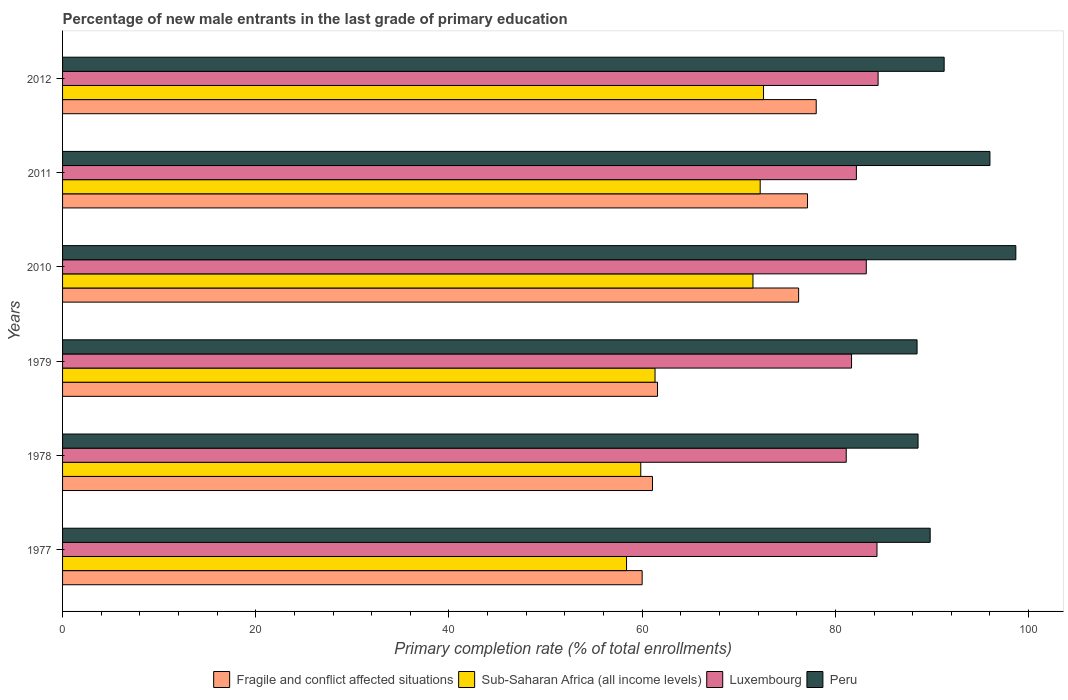Are the number of bars per tick equal to the number of legend labels?
Provide a succinct answer. Yes. Are the number of bars on each tick of the Y-axis equal?
Offer a very short reply. Yes. How many bars are there on the 3rd tick from the top?
Your answer should be compact. 4. How many bars are there on the 1st tick from the bottom?
Ensure brevity in your answer.  4. What is the label of the 5th group of bars from the top?
Your answer should be very brief. 1978. In how many cases, is the number of bars for a given year not equal to the number of legend labels?
Provide a short and direct response. 0. What is the percentage of new male entrants in Luxembourg in 1977?
Your response must be concise. 84.31. Across all years, what is the maximum percentage of new male entrants in Sub-Saharan Africa (all income levels)?
Offer a very short reply. 72.56. Across all years, what is the minimum percentage of new male entrants in Fragile and conflict affected situations?
Ensure brevity in your answer.  60. In which year was the percentage of new male entrants in Sub-Saharan Africa (all income levels) minimum?
Keep it short and to the point. 1977. What is the total percentage of new male entrants in Sub-Saharan Africa (all income levels) in the graph?
Your response must be concise. 395.82. What is the difference between the percentage of new male entrants in Peru in 1978 and that in 2011?
Offer a very short reply. -7.44. What is the difference between the percentage of new male entrants in Luxembourg in 1979 and the percentage of new male entrants in Peru in 2012?
Make the answer very short. -9.59. What is the average percentage of new male entrants in Peru per year?
Make the answer very short. 92.13. In the year 1977, what is the difference between the percentage of new male entrants in Peru and percentage of new male entrants in Luxembourg?
Your answer should be very brief. 5.51. What is the ratio of the percentage of new male entrants in Sub-Saharan Africa (all income levels) in 1977 to that in 2011?
Your response must be concise. 0.81. Is the difference between the percentage of new male entrants in Peru in 1979 and 2011 greater than the difference between the percentage of new male entrants in Luxembourg in 1979 and 2011?
Ensure brevity in your answer.  No. What is the difference between the highest and the second highest percentage of new male entrants in Luxembourg?
Ensure brevity in your answer.  0.12. What is the difference between the highest and the lowest percentage of new male entrants in Luxembourg?
Provide a succinct answer. 3.3. In how many years, is the percentage of new male entrants in Fragile and conflict affected situations greater than the average percentage of new male entrants in Fragile and conflict affected situations taken over all years?
Offer a very short reply. 3. Is the sum of the percentage of new male entrants in Luxembourg in 2010 and 2012 greater than the maximum percentage of new male entrants in Peru across all years?
Ensure brevity in your answer.  Yes. Is it the case that in every year, the sum of the percentage of new male entrants in Sub-Saharan Africa (all income levels) and percentage of new male entrants in Luxembourg is greater than the sum of percentage of new male entrants in Peru and percentage of new male entrants in Fragile and conflict affected situations?
Your response must be concise. No. What does the 4th bar from the top in 2011 represents?
Ensure brevity in your answer.  Fragile and conflict affected situations. What does the 3rd bar from the bottom in 2011 represents?
Provide a short and direct response. Luxembourg. Is it the case that in every year, the sum of the percentage of new male entrants in Luxembourg and percentage of new male entrants in Fragile and conflict affected situations is greater than the percentage of new male entrants in Peru?
Your answer should be compact. Yes. Does the graph contain any zero values?
Offer a very short reply. No. Does the graph contain grids?
Make the answer very short. No. Where does the legend appear in the graph?
Give a very brief answer. Bottom center. How many legend labels are there?
Your answer should be very brief. 4. What is the title of the graph?
Provide a short and direct response. Percentage of new male entrants in the last grade of primary education. What is the label or title of the X-axis?
Keep it short and to the point. Primary completion rate (% of total enrollments). What is the Primary completion rate (% of total enrollments) of Fragile and conflict affected situations in 1977?
Give a very brief answer. 60. What is the Primary completion rate (% of total enrollments) in Sub-Saharan Africa (all income levels) in 1977?
Provide a succinct answer. 58.38. What is the Primary completion rate (% of total enrollments) in Luxembourg in 1977?
Your answer should be compact. 84.31. What is the Primary completion rate (% of total enrollments) of Peru in 1977?
Your answer should be compact. 89.82. What is the Primary completion rate (% of total enrollments) of Fragile and conflict affected situations in 1978?
Offer a terse response. 61.07. What is the Primary completion rate (% of total enrollments) in Sub-Saharan Africa (all income levels) in 1978?
Provide a succinct answer. 59.85. What is the Primary completion rate (% of total enrollments) in Luxembourg in 1978?
Your answer should be very brief. 81.13. What is the Primary completion rate (% of total enrollments) of Peru in 1978?
Provide a short and direct response. 88.56. What is the Primary completion rate (% of total enrollments) of Fragile and conflict affected situations in 1979?
Give a very brief answer. 61.59. What is the Primary completion rate (% of total enrollments) of Sub-Saharan Africa (all income levels) in 1979?
Keep it short and to the point. 61.33. What is the Primary completion rate (% of total enrollments) of Luxembourg in 1979?
Provide a short and direct response. 81.68. What is the Primary completion rate (% of total enrollments) in Peru in 1979?
Your answer should be compact. 88.46. What is the Primary completion rate (% of total enrollments) of Fragile and conflict affected situations in 2010?
Ensure brevity in your answer.  76.2. What is the Primary completion rate (% of total enrollments) in Sub-Saharan Africa (all income levels) in 2010?
Provide a short and direct response. 71.47. What is the Primary completion rate (% of total enrollments) of Luxembourg in 2010?
Offer a very short reply. 83.2. What is the Primary completion rate (% of total enrollments) in Peru in 2010?
Ensure brevity in your answer.  98.68. What is the Primary completion rate (% of total enrollments) of Fragile and conflict affected situations in 2011?
Offer a terse response. 77.12. What is the Primary completion rate (% of total enrollments) in Sub-Saharan Africa (all income levels) in 2011?
Offer a very short reply. 72.22. What is the Primary completion rate (% of total enrollments) in Luxembourg in 2011?
Offer a very short reply. 82.18. What is the Primary completion rate (% of total enrollments) in Peru in 2011?
Your answer should be very brief. 96. What is the Primary completion rate (% of total enrollments) of Fragile and conflict affected situations in 2012?
Offer a terse response. 78.02. What is the Primary completion rate (% of total enrollments) of Sub-Saharan Africa (all income levels) in 2012?
Make the answer very short. 72.56. What is the Primary completion rate (% of total enrollments) of Luxembourg in 2012?
Offer a very short reply. 84.42. What is the Primary completion rate (% of total enrollments) in Peru in 2012?
Keep it short and to the point. 91.26. Across all years, what is the maximum Primary completion rate (% of total enrollments) of Fragile and conflict affected situations?
Your answer should be compact. 78.02. Across all years, what is the maximum Primary completion rate (% of total enrollments) of Sub-Saharan Africa (all income levels)?
Ensure brevity in your answer.  72.56. Across all years, what is the maximum Primary completion rate (% of total enrollments) in Luxembourg?
Offer a very short reply. 84.42. Across all years, what is the maximum Primary completion rate (% of total enrollments) in Peru?
Offer a very short reply. 98.68. Across all years, what is the minimum Primary completion rate (% of total enrollments) of Fragile and conflict affected situations?
Offer a terse response. 60. Across all years, what is the minimum Primary completion rate (% of total enrollments) in Sub-Saharan Africa (all income levels)?
Offer a very short reply. 58.38. Across all years, what is the minimum Primary completion rate (% of total enrollments) of Luxembourg?
Provide a succinct answer. 81.13. Across all years, what is the minimum Primary completion rate (% of total enrollments) of Peru?
Your response must be concise. 88.46. What is the total Primary completion rate (% of total enrollments) of Fragile and conflict affected situations in the graph?
Provide a succinct answer. 413.99. What is the total Primary completion rate (% of total enrollments) in Sub-Saharan Africa (all income levels) in the graph?
Your response must be concise. 395.82. What is the total Primary completion rate (% of total enrollments) of Luxembourg in the graph?
Keep it short and to the point. 496.91. What is the total Primary completion rate (% of total enrollments) in Peru in the graph?
Your answer should be very brief. 552.78. What is the difference between the Primary completion rate (% of total enrollments) in Fragile and conflict affected situations in 1977 and that in 1978?
Your answer should be very brief. -1.07. What is the difference between the Primary completion rate (% of total enrollments) in Sub-Saharan Africa (all income levels) in 1977 and that in 1978?
Your answer should be very brief. -1.47. What is the difference between the Primary completion rate (% of total enrollments) in Luxembourg in 1977 and that in 1978?
Your answer should be compact. 3.18. What is the difference between the Primary completion rate (% of total enrollments) in Peru in 1977 and that in 1978?
Your answer should be compact. 1.25. What is the difference between the Primary completion rate (% of total enrollments) of Fragile and conflict affected situations in 1977 and that in 1979?
Keep it short and to the point. -1.59. What is the difference between the Primary completion rate (% of total enrollments) of Sub-Saharan Africa (all income levels) in 1977 and that in 1979?
Offer a terse response. -2.95. What is the difference between the Primary completion rate (% of total enrollments) in Luxembourg in 1977 and that in 1979?
Give a very brief answer. 2.63. What is the difference between the Primary completion rate (% of total enrollments) in Peru in 1977 and that in 1979?
Ensure brevity in your answer.  1.36. What is the difference between the Primary completion rate (% of total enrollments) of Fragile and conflict affected situations in 1977 and that in 2010?
Give a very brief answer. -16.2. What is the difference between the Primary completion rate (% of total enrollments) of Sub-Saharan Africa (all income levels) in 1977 and that in 2010?
Provide a succinct answer. -13.09. What is the difference between the Primary completion rate (% of total enrollments) in Luxembourg in 1977 and that in 2010?
Your answer should be compact. 1.11. What is the difference between the Primary completion rate (% of total enrollments) of Peru in 1977 and that in 2010?
Keep it short and to the point. -8.87. What is the difference between the Primary completion rate (% of total enrollments) of Fragile and conflict affected situations in 1977 and that in 2011?
Your answer should be very brief. -17.12. What is the difference between the Primary completion rate (% of total enrollments) in Sub-Saharan Africa (all income levels) in 1977 and that in 2011?
Offer a very short reply. -13.83. What is the difference between the Primary completion rate (% of total enrollments) of Luxembourg in 1977 and that in 2011?
Your answer should be compact. 2.13. What is the difference between the Primary completion rate (% of total enrollments) of Peru in 1977 and that in 2011?
Ensure brevity in your answer.  -6.19. What is the difference between the Primary completion rate (% of total enrollments) in Fragile and conflict affected situations in 1977 and that in 2012?
Provide a succinct answer. -18.02. What is the difference between the Primary completion rate (% of total enrollments) in Sub-Saharan Africa (all income levels) in 1977 and that in 2012?
Your response must be concise. -14.18. What is the difference between the Primary completion rate (% of total enrollments) in Luxembourg in 1977 and that in 2012?
Your response must be concise. -0.12. What is the difference between the Primary completion rate (% of total enrollments) in Peru in 1977 and that in 2012?
Make the answer very short. -1.45. What is the difference between the Primary completion rate (% of total enrollments) in Fragile and conflict affected situations in 1978 and that in 1979?
Keep it short and to the point. -0.52. What is the difference between the Primary completion rate (% of total enrollments) in Sub-Saharan Africa (all income levels) in 1978 and that in 1979?
Make the answer very short. -1.48. What is the difference between the Primary completion rate (% of total enrollments) in Luxembourg in 1978 and that in 1979?
Offer a terse response. -0.55. What is the difference between the Primary completion rate (% of total enrollments) of Peru in 1978 and that in 1979?
Ensure brevity in your answer.  0.1. What is the difference between the Primary completion rate (% of total enrollments) in Fragile and conflict affected situations in 1978 and that in 2010?
Offer a very short reply. -15.13. What is the difference between the Primary completion rate (% of total enrollments) of Sub-Saharan Africa (all income levels) in 1978 and that in 2010?
Ensure brevity in your answer.  -11.62. What is the difference between the Primary completion rate (% of total enrollments) of Luxembourg in 1978 and that in 2010?
Your response must be concise. -2.08. What is the difference between the Primary completion rate (% of total enrollments) of Peru in 1978 and that in 2010?
Offer a very short reply. -10.12. What is the difference between the Primary completion rate (% of total enrollments) of Fragile and conflict affected situations in 1978 and that in 2011?
Keep it short and to the point. -16.05. What is the difference between the Primary completion rate (% of total enrollments) in Sub-Saharan Africa (all income levels) in 1978 and that in 2011?
Give a very brief answer. -12.36. What is the difference between the Primary completion rate (% of total enrollments) of Luxembourg in 1978 and that in 2011?
Provide a short and direct response. -1.05. What is the difference between the Primary completion rate (% of total enrollments) of Peru in 1978 and that in 2011?
Your answer should be compact. -7.44. What is the difference between the Primary completion rate (% of total enrollments) in Fragile and conflict affected situations in 1978 and that in 2012?
Provide a short and direct response. -16.95. What is the difference between the Primary completion rate (% of total enrollments) in Sub-Saharan Africa (all income levels) in 1978 and that in 2012?
Keep it short and to the point. -12.71. What is the difference between the Primary completion rate (% of total enrollments) in Luxembourg in 1978 and that in 2012?
Offer a terse response. -3.3. What is the difference between the Primary completion rate (% of total enrollments) of Peru in 1978 and that in 2012?
Give a very brief answer. -2.7. What is the difference between the Primary completion rate (% of total enrollments) in Fragile and conflict affected situations in 1979 and that in 2010?
Your answer should be compact. -14.61. What is the difference between the Primary completion rate (% of total enrollments) of Sub-Saharan Africa (all income levels) in 1979 and that in 2010?
Your answer should be very brief. -10.14. What is the difference between the Primary completion rate (% of total enrollments) of Luxembourg in 1979 and that in 2010?
Offer a very short reply. -1.52. What is the difference between the Primary completion rate (% of total enrollments) of Peru in 1979 and that in 2010?
Make the answer very short. -10.22. What is the difference between the Primary completion rate (% of total enrollments) in Fragile and conflict affected situations in 1979 and that in 2011?
Ensure brevity in your answer.  -15.53. What is the difference between the Primary completion rate (% of total enrollments) of Sub-Saharan Africa (all income levels) in 1979 and that in 2011?
Provide a short and direct response. -10.88. What is the difference between the Primary completion rate (% of total enrollments) of Luxembourg in 1979 and that in 2011?
Keep it short and to the point. -0.5. What is the difference between the Primary completion rate (% of total enrollments) in Peru in 1979 and that in 2011?
Provide a short and direct response. -7.54. What is the difference between the Primary completion rate (% of total enrollments) of Fragile and conflict affected situations in 1979 and that in 2012?
Your answer should be very brief. -16.43. What is the difference between the Primary completion rate (% of total enrollments) of Sub-Saharan Africa (all income levels) in 1979 and that in 2012?
Provide a short and direct response. -11.23. What is the difference between the Primary completion rate (% of total enrollments) in Luxembourg in 1979 and that in 2012?
Provide a succinct answer. -2.75. What is the difference between the Primary completion rate (% of total enrollments) in Peru in 1979 and that in 2012?
Ensure brevity in your answer.  -2.8. What is the difference between the Primary completion rate (% of total enrollments) of Fragile and conflict affected situations in 2010 and that in 2011?
Give a very brief answer. -0.92. What is the difference between the Primary completion rate (% of total enrollments) in Sub-Saharan Africa (all income levels) in 2010 and that in 2011?
Provide a succinct answer. -0.75. What is the difference between the Primary completion rate (% of total enrollments) in Luxembourg in 2010 and that in 2011?
Your answer should be compact. 1.02. What is the difference between the Primary completion rate (% of total enrollments) of Peru in 2010 and that in 2011?
Ensure brevity in your answer.  2.68. What is the difference between the Primary completion rate (% of total enrollments) of Fragile and conflict affected situations in 2010 and that in 2012?
Make the answer very short. -1.82. What is the difference between the Primary completion rate (% of total enrollments) of Sub-Saharan Africa (all income levels) in 2010 and that in 2012?
Your answer should be very brief. -1.09. What is the difference between the Primary completion rate (% of total enrollments) in Luxembourg in 2010 and that in 2012?
Provide a succinct answer. -1.22. What is the difference between the Primary completion rate (% of total enrollments) in Peru in 2010 and that in 2012?
Your response must be concise. 7.42. What is the difference between the Primary completion rate (% of total enrollments) in Fragile and conflict affected situations in 2011 and that in 2012?
Provide a succinct answer. -0.9. What is the difference between the Primary completion rate (% of total enrollments) in Sub-Saharan Africa (all income levels) in 2011 and that in 2012?
Your answer should be compact. -0.35. What is the difference between the Primary completion rate (% of total enrollments) of Luxembourg in 2011 and that in 2012?
Provide a succinct answer. -2.25. What is the difference between the Primary completion rate (% of total enrollments) in Peru in 2011 and that in 2012?
Give a very brief answer. 4.74. What is the difference between the Primary completion rate (% of total enrollments) of Fragile and conflict affected situations in 1977 and the Primary completion rate (% of total enrollments) of Sub-Saharan Africa (all income levels) in 1978?
Make the answer very short. 0.15. What is the difference between the Primary completion rate (% of total enrollments) in Fragile and conflict affected situations in 1977 and the Primary completion rate (% of total enrollments) in Luxembourg in 1978?
Ensure brevity in your answer.  -21.13. What is the difference between the Primary completion rate (% of total enrollments) in Fragile and conflict affected situations in 1977 and the Primary completion rate (% of total enrollments) in Peru in 1978?
Your response must be concise. -28.56. What is the difference between the Primary completion rate (% of total enrollments) in Sub-Saharan Africa (all income levels) in 1977 and the Primary completion rate (% of total enrollments) in Luxembourg in 1978?
Your answer should be very brief. -22.74. What is the difference between the Primary completion rate (% of total enrollments) in Sub-Saharan Africa (all income levels) in 1977 and the Primary completion rate (% of total enrollments) in Peru in 1978?
Offer a very short reply. -30.18. What is the difference between the Primary completion rate (% of total enrollments) of Luxembourg in 1977 and the Primary completion rate (% of total enrollments) of Peru in 1978?
Offer a terse response. -4.25. What is the difference between the Primary completion rate (% of total enrollments) in Fragile and conflict affected situations in 1977 and the Primary completion rate (% of total enrollments) in Sub-Saharan Africa (all income levels) in 1979?
Make the answer very short. -1.33. What is the difference between the Primary completion rate (% of total enrollments) in Fragile and conflict affected situations in 1977 and the Primary completion rate (% of total enrollments) in Luxembourg in 1979?
Your answer should be very brief. -21.68. What is the difference between the Primary completion rate (% of total enrollments) of Fragile and conflict affected situations in 1977 and the Primary completion rate (% of total enrollments) of Peru in 1979?
Offer a terse response. -28.46. What is the difference between the Primary completion rate (% of total enrollments) of Sub-Saharan Africa (all income levels) in 1977 and the Primary completion rate (% of total enrollments) of Luxembourg in 1979?
Your answer should be compact. -23.29. What is the difference between the Primary completion rate (% of total enrollments) of Sub-Saharan Africa (all income levels) in 1977 and the Primary completion rate (% of total enrollments) of Peru in 1979?
Your answer should be compact. -30.07. What is the difference between the Primary completion rate (% of total enrollments) of Luxembourg in 1977 and the Primary completion rate (% of total enrollments) of Peru in 1979?
Offer a very short reply. -4.15. What is the difference between the Primary completion rate (% of total enrollments) in Fragile and conflict affected situations in 1977 and the Primary completion rate (% of total enrollments) in Sub-Saharan Africa (all income levels) in 2010?
Your answer should be very brief. -11.47. What is the difference between the Primary completion rate (% of total enrollments) of Fragile and conflict affected situations in 1977 and the Primary completion rate (% of total enrollments) of Luxembourg in 2010?
Your answer should be compact. -23.2. What is the difference between the Primary completion rate (% of total enrollments) of Fragile and conflict affected situations in 1977 and the Primary completion rate (% of total enrollments) of Peru in 2010?
Ensure brevity in your answer.  -38.68. What is the difference between the Primary completion rate (% of total enrollments) in Sub-Saharan Africa (all income levels) in 1977 and the Primary completion rate (% of total enrollments) in Luxembourg in 2010?
Provide a succinct answer. -24.82. What is the difference between the Primary completion rate (% of total enrollments) in Sub-Saharan Africa (all income levels) in 1977 and the Primary completion rate (% of total enrollments) in Peru in 2010?
Give a very brief answer. -40.3. What is the difference between the Primary completion rate (% of total enrollments) of Luxembourg in 1977 and the Primary completion rate (% of total enrollments) of Peru in 2010?
Keep it short and to the point. -14.37. What is the difference between the Primary completion rate (% of total enrollments) of Fragile and conflict affected situations in 1977 and the Primary completion rate (% of total enrollments) of Sub-Saharan Africa (all income levels) in 2011?
Offer a very short reply. -12.22. What is the difference between the Primary completion rate (% of total enrollments) in Fragile and conflict affected situations in 1977 and the Primary completion rate (% of total enrollments) in Luxembourg in 2011?
Keep it short and to the point. -22.18. What is the difference between the Primary completion rate (% of total enrollments) in Fragile and conflict affected situations in 1977 and the Primary completion rate (% of total enrollments) in Peru in 2011?
Offer a terse response. -36. What is the difference between the Primary completion rate (% of total enrollments) in Sub-Saharan Africa (all income levels) in 1977 and the Primary completion rate (% of total enrollments) in Luxembourg in 2011?
Provide a succinct answer. -23.79. What is the difference between the Primary completion rate (% of total enrollments) of Sub-Saharan Africa (all income levels) in 1977 and the Primary completion rate (% of total enrollments) of Peru in 2011?
Provide a short and direct response. -37.62. What is the difference between the Primary completion rate (% of total enrollments) in Luxembourg in 1977 and the Primary completion rate (% of total enrollments) in Peru in 2011?
Your answer should be compact. -11.69. What is the difference between the Primary completion rate (% of total enrollments) of Fragile and conflict affected situations in 1977 and the Primary completion rate (% of total enrollments) of Sub-Saharan Africa (all income levels) in 2012?
Provide a succinct answer. -12.56. What is the difference between the Primary completion rate (% of total enrollments) of Fragile and conflict affected situations in 1977 and the Primary completion rate (% of total enrollments) of Luxembourg in 2012?
Your answer should be compact. -24.42. What is the difference between the Primary completion rate (% of total enrollments) of Fragile and conflict affected situations in 1977 and the Primary completion rate (% of total enrollments) of Peru in 2012?
Offer a very short reply. -31.26. What is the difference between the Primary completion rate (% of total enrollments) of Sub-Saharan Africa (all income levels) in 1977 and the Primary completion rate (% of total enrollments) of Luxembourg in 2012?
Provide a succinct answer. -26.04. What is the difference between the Primary completion rate (% of total enrollments) of Sub-Saharan Africa (all income levels) in 1977 and the Primary completion rate (% of total enrollments) of Peru in 2012?
Ensure brevity in your answer.  -32.88. What is the difference between the Primary completion rate (% of total enrollments) in Luxembourg in 1977 and the Primary completion rate (% of total enrollments) in Peru in 2012?
Give a very brief answer. -6.95. What is the difference between the Primary completion rate (% of total enrollments) of Fragile and conflict affected situations in 1978 and the Primary completion rate (% of total enrollments) of Sub-Saharan Africa (all income levels) in 1979?
Ensure brevity in your answer.  -0.26. What is the difference between the Primary completion rate (% of total enrollments) of Fragile and conflict affected situations in 1978 and the Primary completion rate (% of total enrollments) of Luxembourg in 1979?
Offer a terse response. -20.61. What is the difference between the Primary completion rate (% of total enrollments) in Fragile and conflict affected situations in 1978 and the Primary completion rate (% of total enrollments) in Peru in 1979?
Provide a short and direct response. -27.39. What is the difference between the Primary completion rate (% of total enrollments) of Sub-Saharan Africa (all income levels) in 1978 and the Primary completion rate (% of total enrollments) of Luxembourg in 1979?
Provide a short and direct response. -21.82. What is the difference between the Primary completion rate (% of total enrollments) of Sub-Saharan Africa (all income levels) in 1978 and the Primary completion rate (% of total enrollments) of Peru in 1979?
Your response must be concise. -28.6. What is the difference between the Primary completion rate (% of total enrollments) of Luxembourg in 1978 and the Primary completion rate (% of total enrollments) of Peru in 1979?
Provide a short and direct response. -7.33. What is the difference between the Primary completion rate (% of total enrollments) of Fragile and conflict affected situations in 1978 and the Primary completion rate (% of total enrollments) of Luxembourg in 2010?
Provide a short and direct response. -22.13. What is the difference between the Primary completion rate (% of total enrollments) of Fragile and conflict affected situations in 1978 and the Primary completion rate (% of total enrollments) of Peru in 2010?
Ensure brevity in your answer.  -37.61. What is the difference between the Primary completion rate (% of total enrollments) of Sub-Saharan Africa (all income levels) in 1978 and the Primary completion rate (% of total enrollments) of Luxembourg in 2010?
Offer a very short reply. -23.35. What is the difference between the Primary completion rate (% of total enrollments) in Sub-Saharan Africa (all income levels) in 1978 and the Primary completion rate (% of total enrollments) in Peru in 2010?
Keep it short and to the point. -38.83. What is the difference between the Primary completion rate (% of total enrollments) of Luxembourg in 1978 and the Primary completion rate (% of total enrollments) of Peru in 2010?
Ensure brevity in your answer.  -17.56. What is the difference between the Primary completion rate (% of total enrollments) in Fragile and conflict affected situations in 1978 and the Primary completion rate (% of total enrollments) in Sub-Saharan Africa (all income levels) in 2011?
Your answer should be very brief. -11.15. What is the difference between the Primary completion rate (% of total enrollments) of Fragile and conflict affected situations in 1978 and the Primary completion rate (% of total enrollments) of Luxembourg in 2011?
Give a very brief answer. -21.11. What is the difference between the Primary completion rate (% of total enrollments) of Fragile and conflict affected situations in 1978 and the Primary completion rate (% of total enrollments) of Peru in 2011?
Your answer should be compact. -34.93. What is the difference between the Primary completion rate (% of total enrollments) in Sub-Saharan Africa (all income levels) in 1978 and the Primary completion rate (% of total enrollments) in Luxembourg in 2011?
Offer a terse response. -22.32. What is the difference between the Primary completion rate (% of total enrollments) in Sub-Saharan Africa (all income levels) in 1978 and the Primary completion rate (% of total enrollments) in Peru in 2011?
Your answer should be compact. -36.15. What is the difference between the Primary completion rate (% of total enrollments) of Luxembourg in 1978 and the Primary completion rate (% of total enrollments) of Peru in 2011?
Keep it short and to the point. -14.88. What is the difference between the Primary completion rate (% of total enrollments) of Fragile and conflict affected situations in 1978 and the Primary completion rate (% of total enrollments) of Sub-Saharan Africa (all income levels) in 2012?
Make the answer very short. -11.49. What is the difference between the Primary completion rate (% of total enrollments) in Fragile and conflict affected situations in 1978 and the Primary completion rate (% of total enrollments) in Luxembourg in 2012?
Give a very brief answer. -23.35. What is the difference between the Primary completion rate (% of total enrollments) of Fragile and conflict affected situations in 1978 and the Primary completion rate (% of total enrollments) of Peru in 2012?
Keep it short and to the point. -30.19. What is the difference between the Primary completion rate (% of total enrollments) of Sub-Saharan Africa (all income levels) in 1978 and the Primary completion rate (% of total enrollments) of Luxembourg in 2012?
Keep it short and to the point. -24.57. What is the difference between the Primary completion rate (% of total enrollments) of Sub-Saharan Africa (all income levels) in 1978 and the Primary completion rate (% of total enrollments) of Peru in 2012?
Offer a terse response. -31.41. What is the difference between the Primary completion rate (% of total enrollments) of Luxembourg in 1978 and the Primary completion rate (% of total enrollments) of Peru in 2012?
Your response must be concise. -10.14. What is the difference between the Primary completion rate (% of total enrollments) of Fragile and conflict affected situations in 1979 and the Primary completion rate (% of total enrollments) of Sub-Saharan Africa (all income levels) in 2010?
Provide a short and direct response. -9.88. What is the difference between the Primary completion rate (% of total enrollments) of Fragile and conflict affected situations in 1979 and the Primary completion rate (% of total enrollments) of Luxembourg in 2010?
Offer a terse response. -21.61. What is the difference between the Primary completion rate (% of total enrollments) of Fragile and conflict affected situations in 1979 and the Primary completion rate (% of total enrollments) of Peru in 2010?
Give a very brief answer. -37.09. What is the difference between the Primary completion rate (% of total enrollments) in Sub-Saharan Africa (all income levels) in 1979 and the Primary completion rate (% of total enrollments) in Luxembourg in 2010?
Your answer should be very brief. -21.87. What is the difference between the Primary completion rate (% of total enrollments) of Sub-Saharan Africa (all income levels) in 1979 and the Primary completion rate (% of total enrollments) of Peru in 2010?
Make the answer very short. -37.35. What is the difference between the Primary completion rate (% of total enrollments) in Luxembourg in 1979 and the Primary completion rate (% of total enrollments) in Peru in 2010?
Offer a very short reply. -17.01. What is the difference between the Primary completion rate (% of total enrollments) of Fragile and conflict affected situations in 1979 and the Primary completion rate (% of total enrollments) of Sub-Saharan Africa (all income levels) in 2011?
Make the answer very short. -10.63. What is the difference between the Primary completion rate (% of total enrollments) of Fragile and conflict affected situations in 1979 and the Primary completion rate (% of total enrollments) of Luxembourg in 2011?
Provide a short and direct response. -20.59. What is the difference between the Primary completion rate (% of total enrollments) of Fragile and conflict affected situations in 1979 and the Primary completion rate (% of total enrollments) of Peru in 2011?
Offer a very short reply. -34.41. What is the difference between the Primary completion rate (% of total enrollments) of Sub-Saharan Africa (all income levels) in 1979 and the Primary completion rate (% of total enrollments) of Luxembourg in 2011?
Provide a short and direct response. -20.84. What is the difference between the Primary completion rate (% of total enrollments) of Sub-Saharan Africa (all income levels) in 1979 and the Primary completion rate (% of total enrollments) of Peru in 2011?
Your answer should be very brief. -34.67. What is the difference between the Primary completion rate (% of total enrollments) of Luxembourg in 1979 and the Primary completion rate (% of total enrollments) of Peru in 2011?
Ensure brevity in your answer.  -14.33. What is the difference between the Primary completion rate (% of total enrollments) of Fragile and conflict affected situations in 1979 and the Primary completion rate (% of total enrollments) of Sub-Saharan Africa (all income levels) in 2012?
Your answer should be very brief. -10.97. What is the difference between the Primary completion rate (% of total enrollments) in Fragile and conflict affected situations in 1979 and the Primary completion rate (% of total enrollments) in Luxembourg in 2012?
Your answer should be compact. -22.84. What is the difference between the Primary completion rate (% of total enrollments) of Fragile and conflict affected situations in 1979 and the Primary completion rate (% of total enrollments) of Peru in 2012?
Provide a short and direct response. -29.67. What is the difference between the Primary completion rate (% of total enrollments) in Sub-Saharan Africa (all income levels) in 1979 and the Primary completion rate (% of total enrollments) in Luxembourg in 2012?
Your response must be concise. -23.09. What is the difference between the Primary completion rate (% of total enrollments) in Sub-Saharan Africa (all income levels) in 1979 and the Primary completion rate (% of total enrollments) in Peru in 2012?
Offer a very short reply. -29.93. What is the difference between the Primary completion rate (% of total enrollments) of Luxembourg in 1979 and the Primary completion rate (% of total enrollments) of Peru in 2012?
Provide a short and direct response. -9.59. What is the difference between the Primary completion rate (% of total enrollments) of Fragile and conflict affected situations in 2010 and the Primary completion rate (% of total enrollments) of Sub-Saharan Africa (all income levels) in 2011?
Offer a very short reply. 3.98. What is the difference between the Primary completion rate (% of total enrollments) in Fragile and conflict affected situations in 2010 and the Primary completion rate (% of total enrollments) in Luxembourg in 2011?
Your response must be concise. -5.98. What is the difference between the Primary completion rate (% of total enrollments) of Fragile and conflict affected situations in 2010 and the Primary completion rate (% of total enrollments) of Peru in 2011?
Your answer should be very brief. -19.81. What is the difference between the Primary completion rate (% of total enrollments) in Sub-Saharan Africa (all income levels) in 2010 and the Primary completion rate (% of total enrollments) in Luxembourg in 2011?
Provide a short and direct response. -10.71. What is the difference between the Primary completion rate (% of total enrollments) of Sub-Saharan Africa (all income levels) in 2010 and the Primary completion rate (% of total enrollments) of Peru in 2011?
Provide a succinct answer. -24.53. What is the difference between the Primary completion rate (% of total enrollments) in Luxembourg in 2010 and the Primary completion rate (% of total enrollments) in Peru in 2011?
Give a very brief answer. -12.8. What is the difference between the Primary completion rate (% of total enrollments) in Fragile and conflict affected situations in 2010 and the Primary completion rate (% of total enrollments) in Sub-Saharan Africa (all income levels) in 2012?
Your answer should be compact. 3.63. What is the difference between the Primary completion rate (% of total enrollments) of Fragile and conflict affected situations in 2010 and the Primary completion rate (% of total enrollments) of Luxembourg in 2012?
Make the answer very short. -8.23. What is the difference between the Primary completion rate (% of total enrollments) of Fragile and conflict affected situations in 2010 and the Primary completion rate (% of total enrollments) of Peru in 2012?
Your response must be concise. -15.07. What is the difference between the Primary completion rate (% of total enrollments) in Sub-Saharan Africa (all income levels) in 2010 and the Primary completion rate (% of total enrollments) in Luxembourg in 2012?
Provide a succinct answer. -12.95. What is the difference between the Primary completion rate (% of total enrollments) in Sub-Saharan Africa (all income levels) in 2010 and the Primary completion rate (% of total enrollments) in Peru in 2012?
Make the answer very short. -19.79. What is the difference between the Primary completion rate (% of total enrollments) in Luxembourg in 2010 and the Primary completion rate (% of total enrollments) in Peru in 2012?
Provide a short and direct response. -8.06. What is the difference between the Primary completion rate (% of total enrollments) of Fragile and conflict affected situations in 2011 and the Primary completion rate (% of total enrollments) of Sub-Saharan Africa (all income levels) in 2012?
Ensure brevity in your answer.  4.55. What is the difference between the Primary completion rate (% of total enrollments) of Fragile and conflict affected situations in 2011 and the Primary completion rate (% of total enrollments) of Luxembourg in 2012?
Your answer should be compact. -7.31. What is the difference between the Primary completion rate (% of total enrollments) in Fragile and conflict affected situations in 2011 and the Primary completion rate (% of total enrollments) in Peru in 2012?
Offer a terse response. -14.15. What is the difference between the Primary completion rate (% of total enrollments) in Sub-Saharan Africa (all income levels) in 2011 and the Primary completion rate (% of total enrollments) in Luxembourg in 2012?
Ensure brevity in your answer.  -12.21. What is the difference between the Primary completion rate (% of total enrollments) of Sub-Saharan Africa (all income levels) in 2011 and the Primary completion rate (% of total enrollments) of Peru in 2012?
Make the answer very short. -19.05. What is the difference between the Primary completion rate (% of total enrollments) of Luxembourg in 2011 and the Primary completion rate (% of total enrollments) of Peru in 2012?
Offer a terse response. -9.09. What is the average Primary completion rate (% of total enrollments) of Fragile and conflict affected situations per year?
Your response must be concise. 69. What is the average Primary completion rate (% of total enrollments) of Sub-Saharan Africa (all income levels) per year?
Your answer should be compact. 65.97. What is the average Primary completion rate (% of total enrollments) of Luxembourg per year?
Keep it short and to the point. 82.82. What is the average Primary completion rate (% of total enrollments) in Peru per year?
Offer a very short reply. 92.13. In the year 1977, what is the difference between the Primary completion rate (% of total enrollments) of Fragile and conflict affected situations and Primary completion rate (% of total enrollments) of Sub-Saharan Africa (all income levels)?
Make the answer very short. 1.62. In the year 1977, what is the difference between the Primary completion rate (% of total enrollments) in Fragile and conflict affected situations and Primary completion rate (% of total enrollments) in Luxembourg?
Offer a very short reply. -24.31. In the year 1977, what is the difference between the Primary completion rate (% of total enrollments) in Fragile and conflict affected situations and Primary completion rate (% of total enrollments) in Peru?
Offer a very short reply. -29.82. In the year 1977, what is the difference between the Primary completion rate (% of total enrollments) of Sub-Saharan Africa (all income levels) and Primary completion rate (% of total enrollments) of Luxembourg?
Give a very brief answer. -25.93. In the year 1977, what is the difference between the Primary completion rate (% of total enrollments) of Sub-Saharan Africa (all income levels) and Primary completion rate (% of total enrollments) of Peru?
Provide a succinct answer. -31.43. In the year 1977, what is the difference between the Primary completion rate (% of total enrollments) in Luxembourg and Primary completion rate (% of total enrollments) in Peru?
Make the answer very short. -5.51. In the year 1978, what is the difference between the Primary completion rate (% of total enrollments) of Fragile and conflict affected situations and Primary completion rate (% of total enrollments) of Sub-Saharan Africa (all income levels)?
Offer a very short reply. 1.22. In the year 1978, what is the difference between the Primary completion rate (% of total enrollments) in Fragile and conflict affected situations and Primary completion rate (% of total enrollments) in Luxembourg?
Give a very brief answer. -20.05. In the year 1978, what is the difference between the Primary completion rate (% of total enrollments) of Fragile and conflict affected situations and Primary completion rate (% of total enrollments) of Peru?
Your answer should be very brief. -27.49. In the year 1978, what is the difference between the Primary completion rate (% of total enrollments) in Sub-Saharan Africa (all income levels) and Primary completion rate (% of total enrollments) in Luxembourg?
Provide a succinct answer. -21.27. In the year 1978, what is the difference between the Primary completion rate (% of total enrollments) in Sub-Saharan Africa (all income levels) and Primary completion rate (% of total enrollments) in Peru?
Offer a very short reply. -28.71. In the year 1978, what is the difference between the Primary completion rate (% of total enrollments) of Luxembourg and Primary completion rate (% of total enrollments) of Peru?
Keep it short and to the point. -7.44. In the year 1979, what is the difference between the Primary completion rate (% of total enrollments) of Fragile and conflict affected situations and Primary completion rate (% of total enrollments) of Sub-Saharan Africa (all income levels)?
Keep it short and to the point. 0.25. In the year 1979, what is the difference between the Primary completion rate (% of total enrollments) of Fragile and conflict affected situations and Primary completion rate (% of total enrollments) of Luxembourg?
Your response must be concise. -20.09. In the year 1979, what is the difference between the Primary completion rate (% of total enrollments) in Fragile and conflict affected situations and Primary completion rate (% of total enrollments) in Peru?
Your answer should be very brief. -26.87. In the year 1979, what is the difference between the Primary completion rate (% of total enrollments) in Sub-Saharan Africa (all income levels) and Primary completion rate (% of total enrollments) in Luxembourg?
Your answer should be compact. -20.34. In the year 1979, what is the difference between the Primary completion rate (% of total enrollments) of Sub-Saharan Africa (all income levels) and Primary completion rate (% of total enrollments) of Peru?
Make the answer very short. -27.12. In the year 1979, what is the difference between the Primary completion rate (% of total enrollments) of Luxembourg and Primary completion rate (% of total enrollments) of Peru?
Your response must be concise. -6.78. In the year 2010, what is the difference between the Primary completion rate (% of total enrollments) in Fragile and conflict affected situations and Primary completion rate (% of total enrollments) in Sub-Saharan Africa (all income levels)?
Provide a succinct answer. 4.73. In the year 2010, what is the difference between the Primary completion rate (% of total enrollments) of Fragile and conflict affected situations and Primary completion rate (% of total enrollments) of Luxembourg?
Provide a succinct answer. -7. In the year 2010, what is the difference between the Primary completion rate (% of total enrollments) in Fragile and conflict affected situations and Primary completion rate (% of total enrollments) in Peru?
Your answer should be compact. -22.49. In the year 2010, what is the difference between the Primary completion rate (% of total enrollments) of Sub-Saharan Africa (all income levels) and Primary completion rate (% of total enrollments) of Luxembourg?
Keep it short and to the point. -11.73. In the year 2010, what is the difference between the Primary completion rate (% of total enrollments) in Sub-Saharan Africa (all income levels) and Primary completion rate (% of total enrollments) in Peru?
Offer a terse response. -27.21. In the year 2010, what is the difference between the Primary completion rate (% of total enrollments) of Luxembourg and Primary completion rate (% of total enrollments) of Peru?
Ensure brevity in your answer.  -15.48. In the year 2011, what is the difference between the Primary completion rate (% of total enrollments) in Fragile and conflict affected situations and Primary completion rate (% of total enrollments) in Sub-Saharan Africa (all income levels)?
Provide a short and direct response. 4.9. In the year 2011, what is the difference between the Primary completion rate (% of total enrollments) of Fragile and conflict affected situations and Primary completion rate (% of total enrollments) of Luxembourg?
Provide a succinct answer. -5.06. In the year 2011, what is the difference between the Primary completion rate (% of total enrollments) of Fragile and conflict affected situations and Primary completion rate (% of total enrollments) of Peru?
Keep it short and to the point. -18.89. In the year 2011, what is the difference between the Primary completion rate (% of total enrollments) of Sub-Saharan Africa (all income levels) and Primary completion rate (% of total enrollments) of Luxembourg?
Make the answer very short. -9.96. In the year 2011, what is the difference between the Primary completion rate (% of total enrollments) of Sub-Saharan Africa (all income levels) and Primary completion rate (% of total enrollments) of Peru?
Keep it short and to the point. -23.78. In the year 2011, what is the difference between the Primary completion rate (% of total enrollments) of Luxembourg and Primary completion rate (% of total enrollments) of Peru?
Ensure brevity in your answer.  -13.83. In the year 2012, what is the difference between the Primary completion rate (% of total enrollments) in Fragile and conflict affected situations and Primary completion rate (% of total enrollments) in Sub-Saharan Africa (all income levels)?
Keep it short and to the point. 5.46. In the year 2012, what is the difference between the Primary completion rate (% of total enrollments) of Fragile and conflict affected situations and Primary completion rate (% of total enrollments) of Luxembourg?
Your answer should be compact. -6.41. In the year 2012, what is the difference between the Primary completion rate (% of total enrollments) of Fragile and conflict affected situations and Primary completion rate (% of total enrollments) of Peru?
Provide a succinct answer. -13.24. In the year 2012, what is the difference between the Primary completion rate (% of total enrollments) in Sub-Saharan Africa (all income levels) and Primary completion rate (% of total enrollments) in Luxembourg?
Provide a succinct answer. -11.86. In the year 2012, what is the difference between the Primary completion rate (% of total enrollments) of Sub-Saharan Africa (all income levels) and Primary completion rate (% of total enrollments) of Peru?
Your answer should be compact. -18.7. In the year 2012, what is the difference between the Primary completion rate (% of total enrollments) in Luxembourg and Primary completion rate (% of total enrollments) in Peru?
Give a very brief answer. -6.84. What is the ratio of the Primary completion rate (% of total enrollments) in Fragile and conflict affected situations in 1977 to that in 1978?
Offer a terse response. 0.98. What is the ratio of the Primary completion rate (% of total enrollments) of Sub-Saharan Africa (all income levels) in 1977 to that in 1978?
Give a very brief answer. 0.98. What is the ratio of the Primary completion rate (% of total enrollments) in Luxembourg in 1977 to that in 1978?
Your answer should be compact. 1.04. What is the ratio of the Primary completion rate (% of total enrollments) of Peru in 1977 to that in 1978?
Offer a terse response. 1.01. What is the ratio of the Primary completion rate (% of total enrollments) of Fragile and conflict affected situations in 1977 to that in 1979?
Keep it short and to the point. 0.97. What is the ratio of the Primary completion rate (% of total enrollments) of Sub-Saharan Africa (all income levels) in 1977 to that in 1979?
Offer a very short reply. 0.95. What is the ratio of the Primary completion rate (% of total enrollments) of Luxembourg in 1977 to that in 1979?
Your answer should be compact. 1.03. What is the ratio of the Primary completion rate (% of total enrollments) of Peru in 1977 to that in 1979?
Keep it short and to the point. 1.02. What is the ratio of the Primary completion rate (% of total enrollments) of Fragile and conflict affected situations in 1977 to that in 2010?
Keep it short and to the point. 0.79. What is the ratio of the Primary completion rate (% of total enrollments) in Sub-Saharan Africa (all income levels) in 1977 to that in 2010?
Your answer should be compact. 0.82. What is the ratio of the Primary completion rate (% of total enrollments) in Luxembourg in 1977 to that in 2010?
Offer a terse response. 1.01. What is the ratio of the Primary completion rate (% of total enrollments) in Peru in 1977 to that in 2010?
Offer a terse response. 0.91. What is the ratio of the Primary completion rate (% of total enrollments) of Fragile and conflict affected situations in 1977 to that in 2011?
Your response must be concise. 0.78. What is the ratio of the Primary completion rate (% of total enrollments) of Sub-Saharan Africa (all income levels) in 1977 to that in 2011?
Your response must be concise. 0.81. What is the ratio of the Primary completion rate (% of total enrollments) in Luxembourg in 1977 to that in 2011?
Your answer should be very brief. 1.03. What is the ratio of the Primary completion rate (% of total enrollments) in Peru in 1977 to that in 2011?
Keep it short and to the point. 0.94. What is the ratio of the Primary completion rate (% of total enrollments) of Fragile and conflict affected situations in 1977 to that in 2012?
Your response must be concise. 0.77. What is the ratio of the Primary completion rate (% of total enrollments) of Sub-Saharan Africa (all income levels) in 1977 to that in 2012?
Provide a short and direct response. 0.8. What is the ratio of the Primary completion rate (% of total enrollments) of Peru in 1977 to that in 2012?
Your answer should be compact. 0.98. What is the ratio of the Primary completion rate (% of total enrollments) of Fragile and conflict affected situations in 1978 to that in 1979?
Keep it short and to the point. 0.99. What is the ratio of the Primary completion rate (% of total enrollments) in Sub-Saharan Africa (all income levels) in 1978 to that in 1979?
Ensure brevity in your answer.  0.98. What is the ratio of the Primary completion rate (% of total enrollments) in Luxembourg in 1978 to that in 1979?
Make the answer very short. 0.99. What is the ratio of the Primary completion rate (% of total enrollments) of Fragile and conflict affected situations in 1978 to that in 2010?
Your answer should be compact. 0.8. What is the ratio of the Primary completion rate (% of total enrollments) of Sub-Saharan Africa (all income levels) in 1978 to that in 2010?
Make the answer very short. 0.84. What is the ratio of the Primary completion rate (% of total enrollments) of Luxembourg in 1978 to that in 2010?
Your answer should be compact. 0.98. What is the ratio of the Primary completion rate (% of total enrollments) in Peru in 1978 to that in 2010?
Provide a succinct answer. 0.9. What is the ratio of the Primary completion rate (% of total enrollments) of Fragile and conflict affected situations in 1978 to that in 2011?
Offer a terse response. 0.79. What is the ratio of the Primary completion rate (% of total enrollments) in Sub-Saharan Africa (all income levels) in 1978 to that in 2011?
Offer a very short reply. 0.83. What is the ratio of the Primary completion rate (% of total enrollments) in Luxembourg in 1978 to that in 2011?
Offer a terse response. 0.99. What is the ratio of the Primary completion rate (% of total enrollments) in Peru in 1978 to that in 2011?
Offer a terse response. 0.92. What is the ratio of the Primary completion rate (% of total enrollments) in Fragile and conflict affected situations in 1978 to that in 2012?
Your answer should be very brief. 0.78. What is the ratio of the Primary completion rate (% of total enrollments) in Sub-Saharan Africa (all income levels) in 1978 to that in 2012?
Give a very brief answer. 0.82. What is the ratio of the Primary completion rate (% of total enrollments) of Luxembourg in 1978 to that in 2012?
Give a very brief answer. 0.96. What is the ratio of the Primary completion rate (% of total enrollments) of Peru in 1978 to that in 2012?
Provide a short and direct response. 0.97. What is the ratio of the Primary completion rate (% of total enrollments) in Fragile and conflict affected situations in 1979 to that in 2010?
Ensure brevity in your answer.  0.81. What is the ratio of the Primary completion rate (% of total enrollments) of Sub-Saharan Africa (all income levels) in 1979 to that in 2010?
Your response must be concise. 0.86. What is the ratio of the Primary completion rate (% of total enrollments) in Luxembourg in 1979 to that in 2010?
Give a very brief answer. 0.98. What is the ratio of the Primary completion rate (% of total enrollments) of Peru in 1979 to that in 2010?
Keep it short and to the point. 0.9. What is the ratio of the Primary completion rate (% of total enrollments) of Fragile and conflict affected situations in 1979 to that in 2011?
Give a very brief answer. 0.8. What is the ratio of the Primary completion rate (% of total enrollments) of Sub-Saharan Africa (all income levels) in 1979 to that in 2011?
Provide a succinct answer. 0.85. What is the ratio of the Primary completion rate (% of total enrollments) in Peru in 1979 to that in 2011?
Give a very brief answer. 0.92. What is the ratio of the Primary completion rate (% of total enrollments) in Fragile and conflict affected situations in 1979 to that in 2012?
Provide a succinct answer. 0.79. What is the ratio of the Primary completion rate (% of total enrollments) in Sub-Saharan Africa (all income levels) in 1979 to that in 2012?
Offer a terse response. 0.85. What is the ratio of the Primary completion rate (% of total enrollments) in Luxembourg in 1979 to that in 2012?
Ensure brevity in your answer.  0.97. What is the ratio of the Primary completion rate (% of total enrollments) in Peru in 1979 to that in 2012?
Offer a very short reply. 0.97. What is the ratio of the Primary completion rate (% of total enrollments) in Fragile and conflict affected situations in 2010 to that in 2011?
Provide a succinct answer. 0.99. What is the ratio of the Primary completion rate (% of total enrollments) in Sub-Saharan Africa (all income levels) in 2010 to that in 2011?
Provide a short and direct response. 0.99. What is the ratio of the Primary completion rate (% of total enrollments) in Luxembourg in 2010 to that in 2011?
Offer a terse response. 1.01. What is the ratio of the Primary completion rate (% of total enrollments) in Peru in 2010 to that in 2011?
Offer a very short reply. 1.03. What is the ratio of the Primary completion rate (% of total enrollments) in Fragile and conflict affected situations in 2010 to that in 2012?
Your answer should be very brief. 0.98. What is the ratio of the Primary completion rate (% of total enrollments) of Sub-Saharan Africa (all income levels) in 2010 to that in 2012?
Keep it short and to the point. 0.98. What is the ratio of the Primary completion rate (% of total enrollments) of Luxembourg in 2010 to that in 2012?
Keep it short and to the point. 0.99. What is the ratio of the Primary completion rate (% of total enrollments) of Peru in 2010 to that in 2012?
Your answer should be compact. 1.08. What is the ratio of the Primary completion rate (% of total enrollments) of Fragile and conflict affected situations in 2011 to that in 2012?
Your answer should be very brief. 0.99. What is the ratio of the Primary completion rate (% of total enrollments) of Luxembourg in 2011 to that in 2012?
Your answer should be compact. 0.97. What is the ratio of the Primary completion rate (% of total enrollments) of Peru in 2011 to that in 2012?
Provide a succinct answer. 1.05. What is the difference between the highest and the second highest Primary completion rate (% of total enrollments) of Fragile and conflict affected situations?
Offer a very short reply. 0.9. What is the difference between the highest and the second highest Primary completion rate (% of total enrollments) in Sub-Saharan Africa (all income levels)?
Provide a succinct answer. 0.35. What is the difference between the highest and the second highest Primary completion rate (% of total enrollments) of Luxembourg?
Make the answer very short. 0.12. What is the difference between the highest and the second highest Primary completion rate (% of total enrollments) in Peru?
Keep it short and to the point. 2.68. What is the difference between the highest and the lowest Primary completion rate (% of total enrollments) of Fragile and conflict affected situations?
Provide a succinct answer. 18.02. What is the difference between the highest and the lowest Primary completion rate (% of total enrollments) in Sub-Saharan Africa (all income levels)?
Your answer should be very brief. 14.18. What is the difference between the highest and the lowest Primary completion rate (% of total enrollments) of Luxembourg?
Provide a short and direct response. 3.3. What is the difference between the highest and the lowest Primary completion rate (% of total enrollments) of Peru?
Provide a succinct answer. 10.22. 